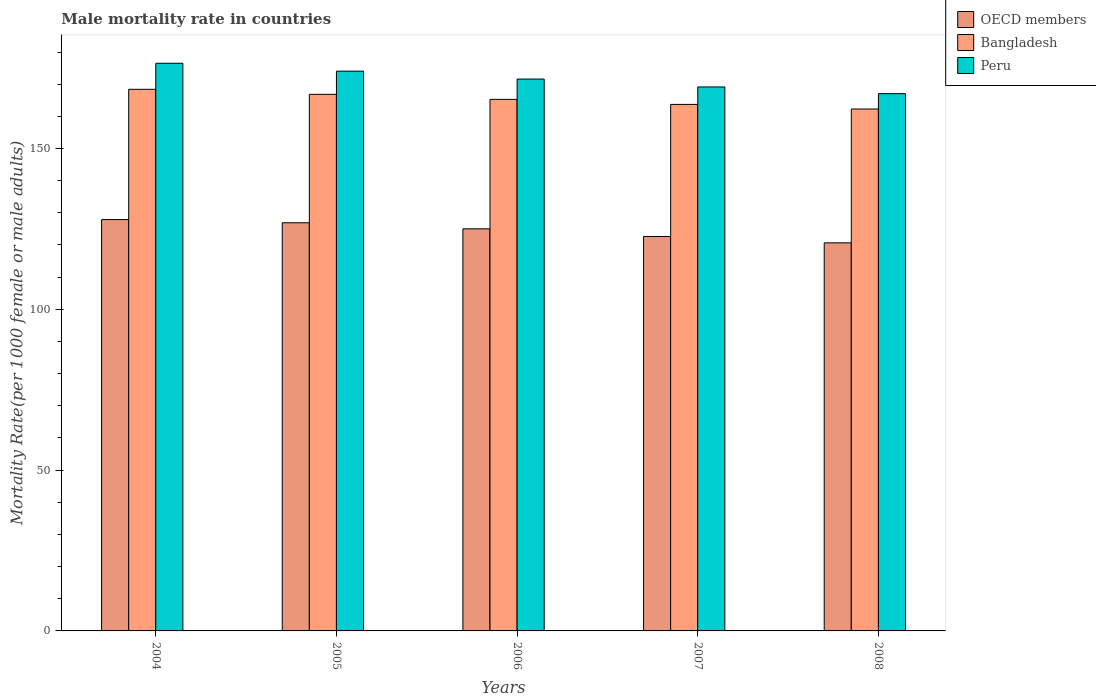How many different coloured bars are there?
Make the answer very short. 3. How many groups of bars are there?
Your answer should be compact. 5. Are the number of bars per tick equal to the number of legend labels?
Keep it short and to the point. Yes. Are the number of bars on each tick of the X-axis equal?
Provide a succinct answer. Yes. How many bars are there on the 3rd tick from the left?
Offer a very short reply. 3. How many bars are there on the 1st tick from the right?
Your answer should be compact. 3. What is the male mortality rate in OECD members in 2004?
Your response must be concise. 127.9. Across all years, what is the maximum male mortality rate in OECD members?
Offer a very short reply. 127.9. Across all years, what is the minimum male mortality rate in OECD members?
Make the answer very short. 120.67. In which year was the male mortality rate in Peru maximum?
Offer a terse response. 2004. In which year was the male mortality rate in Bangladesh minimum?
Your answer should be very brief. 2008. What is the total male mortality rate in Bangladesh in the graph?
Provide a short and direct response. 826.51. What is the difference between the male mortality rate in Peru in 2004 and that in 2005?
Provide a succinct answer. 2.45. What is the difference between the male mortality rate in OECD members in 2006 and the male mortality rate in Bangladesh in 2004?
Make the answer very short. -43.38. What is the average male mortality rate in Bangladesh per year?
Offer a terse response. 165.3. In the year 2006, what is the difference between the male mortality rate in Bangladesh and male mortality rate in Peru?
Your answer should be very brief. -6.32. In how many years, is the male mortality rate in Peru greater than 20?
Ensure brevity in your answer.  5. What is the ratio of the male mortality rate in Peru in 2005 to that in 2008?
Keep it short and to the point. 1.04. Is the difference between the male mortality rate in Bangladesh in 2005 and 2008 greater than the difference between the male mortality rate in Peru in 2005 and 2008?
Offer a very short reply. No. What is the difference between the highest and the second highest male mortality rate in Peru?
Offer a very short reply. 2.45. What is the difference between the highest and the lowest male mortality rate in OECD members?
Offer a terse response. 7.23. In how many years, is the male mortality rate in Peru greater than the average male mortality rate in Peru taken over all years?
Ensure brevity in your answer.  2. What does the 3rd bar from the left in 2005 represents?
Offer a very short reply. Peru. Is it the case that in every year, the sum of the male mortality rate in Bangladesh and male mortality rate in Peru is greater than the male mortality rate in OECD members?
Your response must be concise. Yes. Are all the bars in the graph horizontal?
Your answer should be very brief. No. How many years are there in the graph?
Make the answer very short. 5. What is the difference between two consecutive major ticks on the Y-axis?
Provide a short and direct response. 50. Does the graph contain grids?
Your answer should be compact. No. Where does the legend appear in the graph?
Offer a very short reply. Top right. How are the legend labels stacked?
Your response must be concise. Vertical. What is the title of the graph?
Keep it short and to the point. Male mortality rate in countries. Does "Lebanon" appear as one of the legend labels in the graph?
Offer a terse response. No. What is the label or title of the Y-axis?
Your answer should be compact. Mortality Rate(per 1000 female or male adults). What is the Mortality Rate(per 1000 female or male adults) of OECD members in 2004?
Offer a very short reply. 127.9. What is the Mortality Rate(per 1000 female or male adults) of Bangladesh in 2004?
Ensure brevity in your answer.  168.41. What is the Mortality Rate(per 1000 female or male adults) in Peru in 2004?
Your answer should be very brief. 176.5. What is the Mortality Rate(per 1000 female or male adults) of OECD members in 2005?
Provide a succinct answer. 126.91. What is the Mortality Rate(per 1000 female or male adults) in Bangladesh in 2005?
Provide a short and direct response. 166.84. What is the Mortality Rate(per 1000 female or male adults) in Peru in 2005?
Make the answer very short. 174.05. What is the Mortality Rate(per 1000 female or male adults) of OECD members in 2006?
Keep it short and to the point. 125.03. What is the Mortality Rate(per 1000 female or male adults) in Bangladesh in 2006?
Keep it short and to the point. 165.27. What is the Mortality Rate(per 1000 female or male adults) in Peru in 2006?
Offer a very short reply. 171.59. What is the Mortality Rate(per 1000 female or male adults) in OECD members in 2007?
Your answer should be compact. 122.64. What is the Mortality Rate(per 1000 female or male adults) of Bangladesh in 2007?
Make the answer very short. 163.71. What is the Mortality Rate(per 1000 female or male adults) of Peru in 2007?
Your answer should be very brief. 169.14. What is the Mortality Rate(per 1000 female or male adults) of OECD members in 2008?
Provide a succinct answer. 120.67. What is the Mortality Rate(per 1000 female or male adults) in Bangladesh in 2008?
Provide a succinct answer. 162.28. What is the Mortality Rate(per 1000 female or male adults) of Peru in 2008?
Provide a short and direct response. 167.05. Across all years, what is the maximum Mortality Rate(per 1000 female or male adults) in OECD members?
Ensure brevity in your answer.  127.9. Across all years, what is the maximum Mortality Rate(per 1000 female or male adults) of Bangladesh?
Give a very brief answer. 168.41. Across all years, what is the maximum Mortality Rate(per 1000 female or male adults) of Peru?
Provide a short and direct response. 176.5. Across all years, what is the minimum Mortality Rate(per 1000 female or male adults) of OECD members?
Your answer should be very brief. 120.67. Across all years, what is the minimum Mortality Rate(per 1000 female or male adults) in Bangladesh?
Offer a very short reply. 162.28. Across all years, what is the minimum Mortality Rate(per 1000 female or male adults) in Peru?
Offer a very short reply. 167.05. What is the total Mortality Rate(per 1000 female or male adults) of OECD members in the graph?
Provide a succinct answer. 623.13. What is the total Mortality Rate(per 1000 female or male adults) in Bangladesh in the graph?
Your answer should be compact. 826.51. What is the total Mortality Rate(per 1000 female or male adults) of Peru in the graph?
Make the answer very short. 858.33. What is the difference between the Mortality Rate(per 1000 female or male adults) of Bangladesh in 2004 and that in 2005?
Provide a short and direct response. 1.57. What is the difference between the Mortality Rate(per 1000 female or male adults) of Peru in 2004 and that in 2005?
Offer a very short reply. 2.46. What is the difference between the Mortality Rate(per 1000 female or male adults) of OECD members in 2004 and that in 2006?
Make the answer very short. 2.87. What is the difference between the Mortality Rate(per 1000 female or male adults) in Bangladesh in 2004 and that in 2006?
Offer a terse response. 3.13. What is the difference between the Mortality Rate(per 1000 female or male adults) in Peru in 2004 and that in 2006?
Your answer should be very brief. 4.91. What is the difference between the Mortality Rate(per 1000 female or male adults) of OECD members in 2004 and that in 2007?
Offer a terse response. 5.26. What is the difference between the Mortality Rate(per 1000 female or male adults) in Bangladesh in 2004 and that in 2007?
Ensure brevity in your answer.  4.7. What is the difference between the Mortality Rate(per 1000 female or male adults) in Peru in 2004 and that in 2007?
Offer a very short reply. 7.37. What is the difference between the Mortality Rate(per 1000 female or male adults) in OECD members in 2004 and that in 2008?
Keep it short and to the point. 7.23. What is the difference between the Mortality Rate(per 1000 female or male adults) in Bangladesh in 2004 and that in 2008?
Offer a very short reply. 6.13. What is the difference between the Mortality Rate(per 1000 female or male adults) in Peru in 2004 and that in 2008?
Offer a terse response. 9.46. What is the difference between the Mortality Rate(per 1000 female or male adults) of OECD members in 2005 and that in 2006?
Offer a terse response. 1.88. What is the difference between the Mortality Rate(per 1000 female or male adults) in Bangladesh in 2005 and that in 2006?
Give a very brief answer. 1.57. What is the difference between the Mortality Rate(per 1000 female or male adults) in Peru in 2005 and that in 2006?
Ensure brevity in your answer.  2.46. What is the difference between the Mortality Rate(per 1000 female or male adults) of OECD members in 2005 and that in 2007?
Make the answer very short. 4.27. What is the difference between the Mortality Rate(per 1000 female or male adults) of Bangladesh in 2005 and that in 2007?
Keep it short and to the point. 3.13. What is the difference between the Mortality Rate(per 1000 female or male adults) in Peru in 2005 and that in 2007?
Keep it short and to the point. 4.91. What is the difference between the Mortality Rate(per 1000 female or male adults) of OECD members in 2005 and that in 2008?
Give a very brief answer. 6.24. What is the difference between the Mortality Rate(per 1000 female or male adults) of Bangladesh in 2005 and that in 2008?
Offer a very short reply. 4.56. What is the difference between the Mortality Rate(per 1000 female or male adults) of Peru in 2005 and that in 2008?
Your answer should be very brief. 7. What is the difference between the Mortality Rate(per 1000 female or male adults) of OECD members in 2006 and that in 2007?
Provide a succinct answer. 2.39. What is the difference between the Mortality Rate(per 1000 female or male adults) of Bangladesh in 2006 and that in 2007?
Your response must be concise. 1.57. What is the difference between the Mortality Rate(per 1000 female or male adults) of Peru in 2006 and that in 2007?
Give a very brief answer. 2.46. What is the difference between the Mortality Rate(per 1000 female or male adults) of OECD members in 2006 and that in 2008?
Your response must be concise. 4.36. What is the difference between the Mortality Rate(per 1000 female or male adults) in Bangladesh in 2006 and that in 2008?
Your answer should be very brief. 3. What is the difference between the Mortality Rate(per 1000 female or male adults) of Peru in 2006 and that in 2008?
Provide a succinct answer. 4.55. What is the difference between the Mortality Rate(per 1000 female or male adults) of OECD members in 2007 and that in 2008?
Your answer should be very brief. 1.97. What is the difference between the Mortality Rate(per 1000 female or male adults) in Bangladesh in 2007 and that in 2008?
Your response must be concise. 1.43. What is the difference between the Mortality Rate(per 1000 female or male adults) of Peru in 2007 and that in 2008?
Give a very brief answer. 2.09. What is the difference between the Mortality Rate(per 1000 female or male adults) of OECD members in 2004 and the Mortality Rate(per 1000 female or male adults) of Bangladesh in 2005?
Offer a very short reply. -38.94. What is the difference between the Mortality Rate(per 1000 female or male adults) of OECD members in 2004 and the Mortality Rate(per 1000 female or male adults) of Peru in 2005?
Offer a terse response. -46.15. What is the difference between the Mortality Rate(per 1000 female or male adults) in Bangladesh in 2004 and the Mortality Rate(per 1000 female or male adults) in Peru in 2005?
Give a very brief answer. -5.64. What is the difference between the Mortality Rate(per 1000 female or male adults) of OECD members in 2004 and the Mortality Rate(per 1000 female or male adults) of Bangladesh in 2006?
Your answer should be compact. -37.37. What is the difference between the Mortality Rate(per 1000 female or male adults) in OECD members in 2004 and the Mortality Rate(per 1000 female or male adults) in Peru in 2006?
Make the answer very short. -43.69. What is the difference between the Mortality Rate(per 1000 female or male adults) of Bangladesh in 2004 and the Mortality Rate(per 1000 female or male adults) of Peru in 2006?
Provide a succinct answer. -3.19. What is the difference between the Mortality Rate(per 1000 female or male adults) in OECD members in 2004 and the Mortality Rate(per 1000 female or male adults) in Bangladesh in 2007?
Give a very brief answer. -35.81. What is the difference between the Mortality Rate(per 1000 female or male adults) of OECD members in 2004 and the Mortality Rate(per 1000 female or male adults) of Peru in 2007?
Provide a short and direct response. -41.24. What is the difference between the Mortality Rate(per 1000 female or male adults) in Bangladesh in 2004 and the Mortality Rate(per 1000 female or male adults) in Peru in 2007?
Your answer should be very brief. -0.73. What is the difference between the Mortality Rate(per 1000 female or male adults) of OECD members in 2004 and the Mortality Rate(per 1000 female or male adults) of Bangladesh in 2008?
Your answer should be compact. -34.38. What is the difference between the Mortality Rate(per 1000 female or male adults) in OECD members in 2004 and the Mortality Rate(per 1000 female or male adults) in Peru in 2008?
Offer a very short reply. -39.15. What is the difference between the Mortality Rate(per 1000 female or male adults) of Bangladesh in 2004 and the Mortality Rate(per 1000 female or male adults) of Peru in 2008?
Your answer should be compact. 1.36. What is the difference between the Mortality Rate(per 1000 female or male adults) of OECD members in 2005 and the Mortality Rate(per 1000 female or male adults) of Bangladesh in 2006?
Make the answer very short. -38.37. What is the difference between the Mortality Rate(per 1000 female or male adults) in OECD members in 2005 and the Mortality Rate(per 1000 female or male adults) in Peru in 2006?
Offer a very short reply. -44.69. What is the difference between the Mortality Rate(per 1000 female or male adults) of Bangladesh in 2005 and the Mortality Rate(per 1000 female or male adults) of Peru in 2006?
Your answer should be compact. -4.75. What is the difference between the Mortality Rate(per 1000 female or male adults) of OECD members in 2005 and the Mortality Rate(per 1000 female or male adults) of Bangladesh in 2007?
Provide a succinct answer. -36.8. What is the difference between the Mortality Rate(per 1000 female or male adults) of OECD members in 2005 and the Mortality Rate(per 1000 female or male adults) of Peru in 2007?
Provide a succinct answer. -42.23. What is the difference between the Mortality Rate(per 1000 female or male adults) in Bangladesh in 2005 and the Mortality Rate(per 1000 female or male adults) in Peru in 2007?
Offer a very short reply. -2.3. What is the difference between the Mortality Rate(per 1000 female or male adults) in OECD members in 2005 and the Mortality Rate(per 1000 female or male adults) in Bangladesh in 2008?
Provide a short and direct response. -35.37. What is the difference between the Mortality Rate(per 1000 female or male adults) in OECD members in 2005 and the Mortality Rate(per 1000 female or male adults) in Peru in 2008?
Provide a short and direct response. -40.14. What is the difference between the Mortality Rate(per 1000 female or male adults) in Bangladesh in 2005 and the Mortality Rate(per 1000 female or male adults) in Peru in 2008?
Offer a terse response. -0.2. What is the difference between the Mortality Rate(per 1000 female or male adults) of OECD members in 2006 and the Mortality Rate(per 1000 female or male adults) of Bangladesh in 2007?
Offer a very short reply. -38.68. What is the difference between the Mortality Rate(per 1000 female or male adults) of OECD members in 2006 and the Mortality Rate(per 1000 female or male adults) of Peru in 2007?
Offer a terse response. -44.11. What is the difference between the Mortality Rate(per 1000 female or male adults) in Bangladesh in 2006 and the Mortality Rate(per 1000 female or male adults) in Peru in 2007?
Offer a very short reply. -3.87. What is the difference between the Mortality Rate(per 1000 female or male adults) of OECD members in 2006 and the Mortality Rate(per 1000 female or male adults) of Bangladesh in 2008?
Make the answer very short. -37.25. What is the difference between the Mortality Rate(per 1000 female or male adults) in OECD members in 2006 and the Mortality Rate(per 1000 female or male adults) in Peru in 2008?
Your answer should be compact. -42.02. What is the difference between the Mortality Rate(per 1000 female or male adults) in Bangladesh in 2006 and the Mortality Rate(per 1000 female or male adults) in Peru in 2008?
Provide a short and direct response. -1.77. What is the difference between the Mortality Rate(per 1000 female or male adults) in OECD members in 2007 and the Mortality Rate(per 1000 female or male adults) in Bangladesh in 2008?
Provide a succinct answer. -39.64. What is the difference between the Mortality Rate(per 1000 female or male adults) in OECD members in 2007 and the Mortality Rate(per 1000 female or male adults) in Peru in 2008?
Offer a terse response. -44.41. What is the difference between the Mortality Rate(per 1000 female or male adults) in Bangladesh in 2007 and the Mortality Rate(per 1000 female or male adults) in Peru in 2008?
Ensure brevity in your answer.  -3.34. What is the average Mortality Rate(per 1000 female or male adults) in OECD members per year?
Your response must be concise. 124.63. What is the average Mortality Rate(per 1000 female or male adults) of Bangladesh per year?
Your answer should be very brief. 165.3. What is the average Mortality Rate(per 1000 female or male adults) in Peru per year?
Offer a terse response. 171.67. In the year 2004, what is the difference between the Mortality Rate(per 1000 female or male adults) of OECD members and Mortality Rate(per 1000 female or male adults) of Bangladesh?
Offer a very short reply. -40.51. In the year 2004, what is the difference between the Mortality Rate(per 1000 female or male adults) of OECD members and Mortality Rate(per 1000 female or male adults) of Peru?
Your answer should be compact. -48.6. In the year 2004, what is the difference between the Mortality Rate(per 1000 female or male adults) in Bangladesh and Mortality Rate(per 1000 female or male adults) in Peru?
Provide a short and direct response. -8.1. In the year 2005, what is the difference between the Mortality Rate(per 1000 female or male adults) of OECD members and Mortality Rate(per 1000 female or male adults) of Bangladesh?
Offer a terse response. -39.94. In the year 2005, what is the difference between the Mortality Rate(per 1000 female or male adults) in OECD members and Mortality Rate(per 1000 female or male adults) in Peru?
Give a very brief answer. -47.14. In the year 2005, what is the difference between the Mortality Rate(per 1000 female or male adults) in Bangladesh and Mortality Rate(per 1000 female or male adults) in Peru?
Your response must be concise. -7.21. In the year 2006, what is the difference between the Mortality Rate(per 1000 female or male adults) in OECD members and Mortality Rate(per 1000 female or male adults) in Bangladesh?
Your response must be concise. -40.25. In the year 2006, what is the difference between the Mortality Rate(per 1000 female or male adults) in OECD members and Mortality Rate(per 1000 female or male adults) in Peru?
Make the answer very short. -46.57. In the year 2006, what is the difference between the Mortality Rate(per 1000 female or male adults) in Bangladesh and Mortality Rate(per 1000 female or male adults) in Peru?
Offer a very short reply. -6.32. In the year 2007, what is the difference between the Mortality Rate(per 1000 female or male adults) in OECD members and Mortality Rate(per 1000 female or male adults) in Bangladesh?
Your response must be concise. -41.07. In the year 2007, what is the difference between the Mortality Rate(per 1000 female or male adults) of OECD members and Mortality Rate(per 1000 female or male adults) of Peru?
Your answer should be compact. -46.5. In the year 2007, what is the difference between the Mortality Rate(per 1000 female or male adults) of Bangladesh and Mortality Rate(per 1000 female or male adults) of Peru?
Provide a short and direct response. -5.43. In the year 2008, what is the difference between the Mortality Rate(per 1000 female or male adults) of OECD members and Mortality Rate(per 1000 female or male adults) of Bangladesh?
Your response must be concise. -41.61. In the year 2008, what is the difference between the Mortality Rate(per 1000 female or male adults) in OECD members and Mortality Rate(per 1000 female or male adults) in Peru?
Ensure brevity in your answer.  -46.38. In the year 2008, what is the difference between the Mortality Rate(per 1000 female or male adults) of Bangladesh and Mortality Rate(per 1000 female or male adults) of Peru?
Your answer should be very brief. -4.77. What is the ratio of the Mortality Rate(per 1000 female or male adults) in OECD members in 2004 to that in 2005?
Offer a terse response. 1.01. What is the ratio of the Mortality Rate(per 1000 female or male adults) of Bangladesh in 2004 to that in 2005?
Provide a succinct answer. 1.01. What is the ratio of the Mortality Rate(per 1000 female or male adults) in Peru in 2004 to that in 2005?
Make the answer very short. 1.01. What is the ratio of the Mortality Rate(per 1000 female or male adults) in OECD members in 2004 to that in 2006?
Give a very brief answer. 1.02. What is the ratio of the Mortality Rate(per 1000 female or male adults) in Bangladesh in 2004 to that in 2006?
Provide a short and direct response. 1.02. What is the ratio of the Mortality Rate(per 1000 female or male adults) of Peru in 2004 to that in 2006?
Your answer should be very brief. 1.03. What is the ratio of the Mortality Rate(per 1000 female or male adults) in OECD members in 2004 to that in 2007?
Give a very brief answer. 1.04. What is the ratio of the Mortality Rate(per 1000 female or male adults) of Bangladesh in 2004 to that in 2007?
Give a very brief answer. 1.03. What is the ratio of the Mortality Rate(per 1000 female or male adults) of Peru in 2004 to that in 2007?
Keep it short and to the point. 1.04. What is the ratio of the Mortality Rate(per 1000 female or male adults) of OECD members in 2004 to that in 2008?
Ensure brevity in your answer.  1.06. What is the ratio of the Mortality Rate(per 1000 female or male adults) of Bangladesh in 2004 to that in 2008?
Your answer should be compact. 1.04. What is the ratio of the Mortality Rate(per 1000 female or male adults) of Peru in 2004 to that in 2008?
Keep it short and to the point. 1.06. What is the ratio of the Mortality Rate(per 1000 female or male adults) of OECD members in 2005 to that in 2006?
Your answer should be compact. 1.01. What is the ratio of the Mortality Rate(per 1000 female or male adults) of Bangladesh in 2005 to that in 2006?
Offer a terse response. 1.01. What is the ratio of the Mortality Rate(per 1000 female or male adults) in Peru in 2005 to that in 2006?
Provide a short and direct response. 1.01. What is the ratio of the Mortality Rate(per 1000 female or male adults) of OECD members in 2005 to that in 2007?
Offer a very short reply. 1.03. What is the ratio of the Mortality Rate(per 1000 female or male adults) in Bangladesh in 2005 to that in 2007?
Offer a very short reply. 1.02. What is the ratio of the Mortality Rate(per 1000 female or male adults) in OECD members in 2005 to that in 2008?
Make the answer very short. 1.05. What is the ratio of the Mortality Rate(per 1000 female or male adults) of Bangladesh in 2005 to that in 2008?
Ensure brevity in your answer.  1.03. What is the ratio of the Mortality Rate(per 1000 female or male adults) of Peru in 2005 to that in 2008?
Ensure brevity in your answer.  1.04. What is the ratio of the Mortality Rate(per 1000 female or male adults) in OECD members in 2006 to that in 2007?
Provide a succinct answer. 1.02. What is the ratio of the Mortality Rate(per 1000 female or male adults) in Bangladesh in 2006 to that in 2007?
Your answer should be very brief. 1.01. What is the ratio of the Mortality Rate(per 1000 female or male adults) of Peru in 2006 to that in 2007?
Your answer should be compact. 1.01. What is the ratio of the Mortality Rate(per 1000 female or male adults) in OECD members in 2006 to that in 2008?
Ensure brevity in your answer.  1.04. What is the ratio of the Mortality Rate(per 1000 female or male adults) in Bangladesh in 2006 to that in 2008?
Your answer should be very brief. 1.02. What is the ratio of the Mortality Rate(per 1000 female or male adults) of Peru in 2006 to that in 2008?
Give a very brief answer. 1.03. What is the ratio of the Mortality Rate(per 1000 female or male adults) in OECD members in 2007 to that in 2008?
Offer a terse response. 1.02. What is the ratio of the Mortality Rate(per 1000 female or male adults) of Bangladesh in 2007 to that in 2008?
Your answer should be compact. 1.01. What is the ratio of the Mortality Rate(per 1000 female or male adults) in Peru in 2007 to that in 2008?
Give a very brief answer. 1.01. What is the difference between the highest and the second highest Mortality Rate(per 1000 female or male adults) of Bangladesh?
Keep it short and to the point. 1.57. What is the difference between the highest and the second highest Mortality Rate(per 1000 female or male adults) in Peru?
Keep it short and to the point. 2.46. What is the difference between the highest and the lowest Mortality Rate(per 1000 female or male adults) in OECD members?
Provide a short and direct response. 7.23. What is the difference between the highest and the lowest Mortality Rate(per 1000 female or male adults) in Bangladesh?
Your answer should be very brief. 6.13. What is the difference between the highest and the lowest Mortality Rate(per 1000 female or male adults) of Peru?
Make the answer very short. 9.46. 